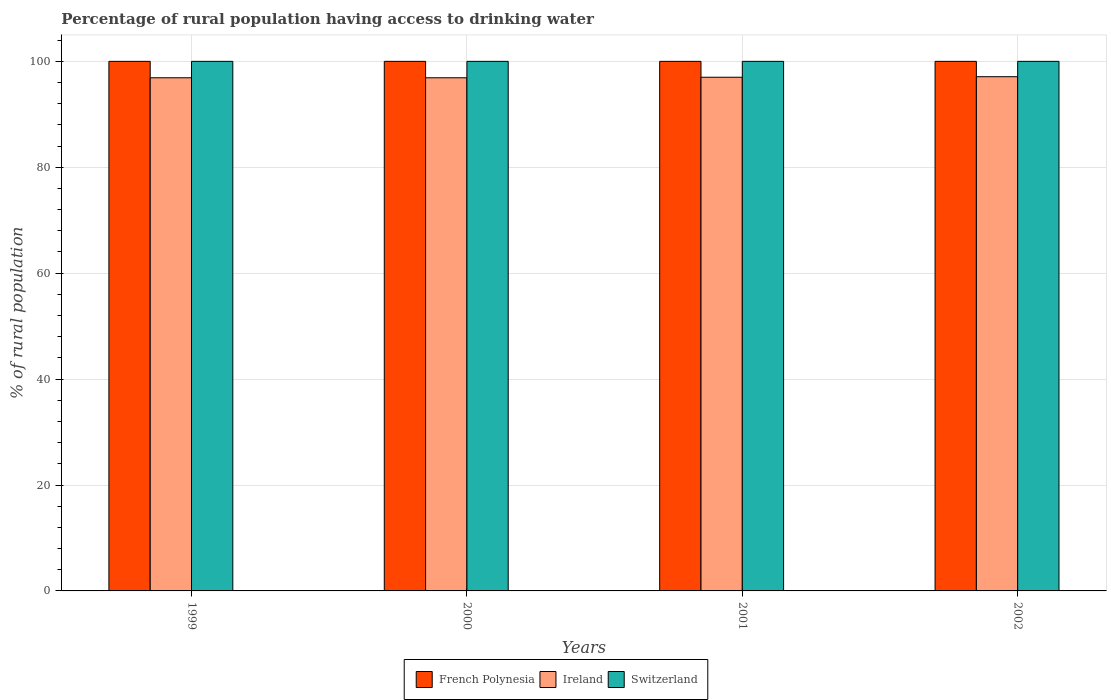How many bars are there on the 3rd tick from the right?
Your response must be concise. 3. What is the percentage of rural population having access to drinking water in Ireland in 1999?
Make the answer very short. 96.9. Across all years, what is the maximum percentage of rural population having access to drinking water in Switzerland?
Give a very brief answer. 100. Across all years, what is the minimum percentage of rural population having access to drinking water in French Polynesia?
Ensure brevity in your answer.  100. What is the total percentage of rural population having access to drinking water in Ireland in the graph?
Your answer should be very brief. 387.9. What is the difference between the percentage of rural population having access to drinking water in French Polynesia in 1999 and that in 2001?
Give a very brief answer. 0. What is the difference between the percentage of rural population having access to drinking water in Ireland in 2000 and the percentage of rural population having access to drinking water in Switzerland in 2002?
Ensure brevity in your answer.  -3.1. In the year 2002, what is the difference between the percentage of rural population having access to drinking water in Ireland and percentage of rural population having access to drinking water in Switzerland?
Ensure brevity in your answer.  -2.9. In how many years, is the percentage of rural population having access to drinking water in French Polynesia greater than 4 %?
Your response must be concise. 4. Is the percentage of rural population having access to drinking water in French Polynesia in 1999 less than that in 2000?
Your response must be concise. No. Is the difference between the percentage of rural population having access to drinking water in Ireland in 2000 and 2001 greater than the difference between the percentage of rural population having access to drinking water in Switzerland in 2000 and 2001?
Your response must be concise. No. What is the difference between the highest and the second highest percentage of rural population having access to drinking water in Ireland?
Your response must be concise. 0.1. What is the difference between the highest and the lowest percentage of rural population having access to drinking water in Ireland?
Offer a very short reply. 0.2. Is the sum of the percentage of rural population having access to drinking water in French Polynesia in 1999 and 2000 greater than the maximum percentage of rural population having access to drinking water in Ireland across all years?
Your answer should be compact. Yes. What does the 1st bar from the left in 2002 represents?
Provide a short and direct response. French Polynesia. What does the 3rd bar from the right in 2001 represents?
Your answer should be compact. French Polynesia. Is it the case that in every year, the sum of the percentage of rural population having access to drinking water in Switzerland and percentage of rural population having access to drinking water in Ireland is greater than the percentage of rural population having access to drinking water in French Polynesia?
Your response must be concise. Yes. How many bars are there?
Ensure brevity in your answer.  12. Are all the bars in the graph horizontal?
Your answer should be compact. No. How many years are there in the graph?
Give a very brief answer. 4. What is the difference between two consecutive major ticks on the Y-axis?
Ensure brevity in your answer.  20. Does the graph contain any zero values?
Provide a succinct answer. No. How are the legend labels stacked?
Provide a succinct answer. Horizontal. What is the title of the graph?
Provide a short and direct response. Percentage of rural population having access to drinking water. What is the label or title of the Y-axis?
Provide a succinct answer. % of rural population. What is the % of rural population of French Polynesia in 1999?
Make the answer very short. 100. What is the % of rural population of Ireland in 1999?
Provide a short and direct response. 96.9. What is the % of rural population in Switzerland in 1999?
Provide a short and direct response. 100. What is the % of rural population in French Polynesia in 2000?
Your response must be concise. 100. What is the % of rural population of Ireland in 2000?
Give a very brief answer. 96.9. What is the % of rural population of Switzerland in 2000?
Keep it short and to the point. 100. What is the % of rural population in Ireland in 2001?
Offer a terse response. 97. What is the % of rural population in Switzerland in 2001?
Your response must be concise. 100. What is the % of rural population of Ireland in 2002?
Give a very brief answer. 97.1. What is the % of rural population in Switzerland in 2002?
Provide a succinct answer. 100. Across all years, what is the maximum % of rural population in Ireland?
Offer a very short reply. 97.1. Across all years, what is the maximum % of rural population in Switzerland?
Keep it short and to the point. 100. Across all years, what is the minimum % of rural population of French Polynesia?
Offer a very short reply. 100. Across all years, what is the minimum % of rural population in Ireland?
Your response must be concise. 96.9. What is the total % of rural population in French Polynesia in the graph?
Provide a short and direct response. 400. What is the total % of rural population in Ireland in the graph?
Your response must be concise. 387.9. What is the total % of rural population in Switzerland in the graph?
Your answer should be compact. 400. What is the difference between the % of rural population in French Polynesia in 1999 and that in 2001?
Provide a succinct answer. 0. What is the difference between the % of rural population in French Polynesia in 1999 and that in 2002?
Provide a short and direct response. 0. What is the difference between the % of rural population in Ireland in 1999 and that in 2002?
Your response must be concise. -0.2. What is the difference between the % of rural population of Switzerland in 1999 and that in 2002?
Your response must be concise. 0. What is the difference between the % of rural population in Ireland in 2000 and that in 2001?
Provide a succinct answer. -0.1. What is the difference between the % of rural population in French Polynesia in 2000 and that in 2002?
Keep it short and to the point. 0. What is the difference between the % of rural population of Ireland in 2000 and that in 2002?
Your answer should be very brief. -0.2. What is the difference between the % of rural population in Switzerland in 2000 and that in 2002?
Your response must be concise. 0. What is the difference between the % of rural population in Switzerland in 2001 and that in 2002?
Keep it short and to the point. 0. What is the difference between the % of rural population in French Polynesia in 1999 and the % of rural population in Switzerland in 2000?
Your response must be concise. 0. What is the difference between the % of rural population of Ireland in 1999 and the % of rural population of Switzerland in 2000?
Give a very brief answer. -3.1. What is the difference between the % of rural population of French Polynesia in 1999 and the % of rural population of Ireland in 2001?
Offer a very short reply. 3. What is the difference between the % of rural population of French Polynesia in 1999 and the % of rural population of Switzerland in 2001?
Your answer should be very brief. 0. What is the difference between the % of rural population of French Polynesia in 2000 and the % of rural population of Ireland in 2001?
Your response must be concise. 3. What is the difference between the % of rural population of French Polynesia in 2000 and the % of rural population of Switzerland in 2001?
Give a very brief answer. 0. What is the difference between the % of rural population in French Polynesia in 2000 and the % of rural population in Switzerland in 2002?
Your response must be concise. 0. What is the difference between the % of rural population of Ireland in 2000 and the % of rural population of Switzerland in 2002?
Your answer should be compact. -3.1. What is the average % of rural population of French Polynesia per year?
Make the answer very short. 100. What is the average % of rural population of Ireland per year?
Provide a succinct answer. 96.97. In the year 1999, what is the difference between the % of rural population of French Polynesia and % of rural population of Switzerland?
Ensure brevity in your answer.  0. In the year 1999, what is the difference between the % of rural population in Ireland and % of rural population in Switzerland?
Offer a terse response. -3.1. In the year 2000, what is the difference between the % of rural population of French Polynesia and % of rural population of Ireland?
Make the answer very short. 3.1. In the year 2001, what is the difference between the % of rural population in Ireland and % of rural population in Switzerland?
Your response must be concise. -3. In the year 2002, what is the difference between the % of rural population in French Polynesia and % of rural population in Ireland?
Keep it short and to the point. 2.9. In the year 2002, what is the difference between the % of rural population in French Polynesia and % of rural population in Switzerland?
Provide a short and direct response. 0. What is the ratio of the % of rural population in French Polynesia in 1999 to that in 2000?
Ensure brevity in your answer.  1. What is the ratio of the % of rural population in Ireland in 1999 to that in 2000?
Give a very brief answer. 1. What is the ratio of the % of rural population in Ireland in 1999 to that in 2001?
Provide a short and direct response. 1. What is the ratio of the % of rural population in Switzerland in 1999 to that in 2001?
Make the answer very short. 1. What is the ratio of the % of rural population in Switzerland in 1999 to that in 2002?
Give a very brief answer. 1. What is the ratio of the % of rural population of French Polynesia in 2000 to that in 2001?
Ensure brevity in your answer.  1. What is the ratio of the % of rural population of Ireland in 2000 to that in 2001?
Provide a succinct answer. 1. What is the ratio of the % of rural population in Switzerland in 2000 to that in 2001?
Provide a short and direct response. 1. What is the ratio of the % of rural population in French Polynesia in 2000 to that in 2002?
Provide a short and direct response. 1. What is the ratio of the % of rural population in French Polynesia in 2001 to that in 2002?
Make the answer very short. 1. What is the ratio of the % of rural population in Switzerland in 2001 to that in 2002?
Provide a succinct answer. 1. What is the difference between the highest and the lowest % of rural population of French Polynesia?
Provide a short and direct response. 0. What is the difference between the highest and the lowest % of rural population of Ireland?
Your answer should be compact. 0.2. What is the difference between the highest and the lowest % of rural population in Switzerland?
Your response must be concise. 0. 